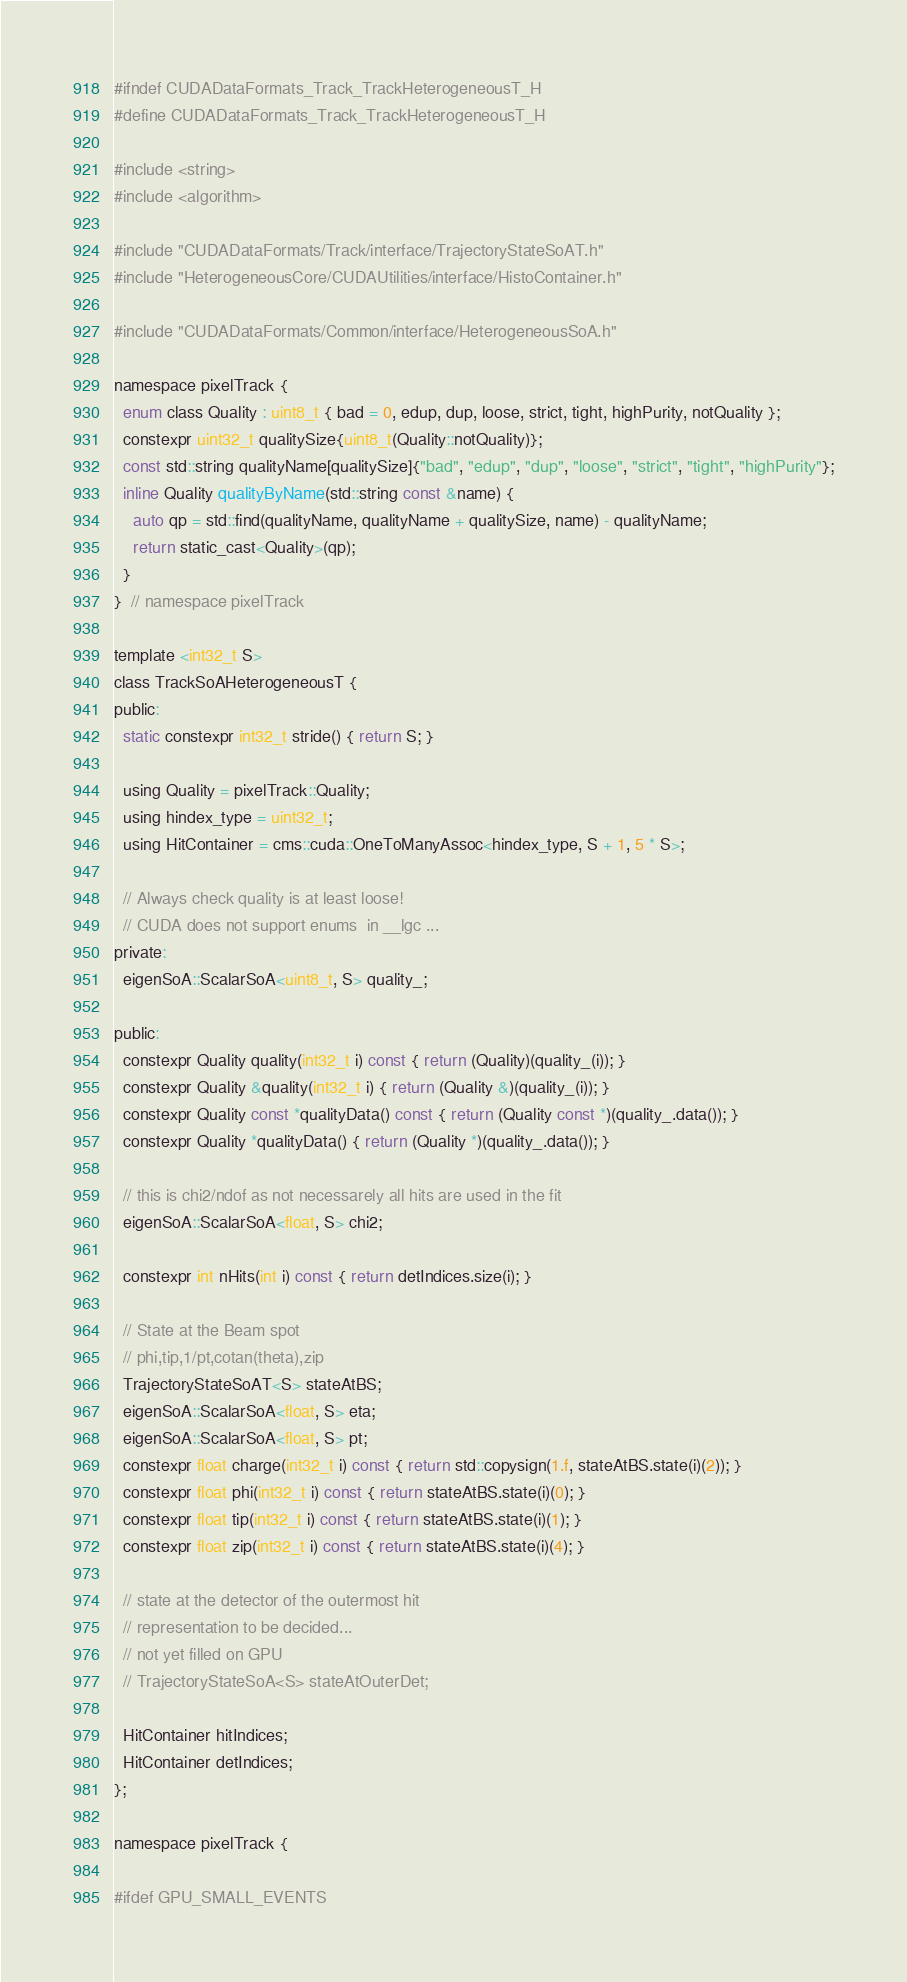<code> <loc_0><loc_0><loc_500><loc_500><_C_>#ifndef CUDADataFormats_Track_TrackHeterogeneousT_H
#define CUDADataFormats_Track_TrackHeterogeneousT_H

#include <string>
#include <algorithm>

#include "CUDADataFormats/Track/interface/TrajectoryStateSoAT.h"
#include "HeterogeneousCore/CUDAUtilities/interface/HistoContainer.h"

#include "CUDADataFormats/Common/interface/HeterogeneousSoA.h"

namespace pixelTrack {
  enum class Quality : uint8_t { bad = 0, edup, dup, loose, strict, tight, highPurity, notQuality };
  constexpr uint32_t qualitySize{uint8_t(Quality::notQuality)};
  const std::string qualityName[qualitySize]{"bad", "edup", "dup", "loose", "strict", "tight", "highPurity"};
  inline Quality qualityByName(std::string const &name) {
    auto qp = std::find(qualityName, qualityName + qualitySize, name) - qualityName;
    return static_cast<Quality>(qp);
  }
}  // namespace pixelTrack

template <int32_t S>
class TrackSoAHeterogeneousT {
public:
  static constexpr int32_t stride() { return S; }

  using Quality = pixelTrack::Quality;
  using hindex_type = uint32_t;
  using HitContainer = cms::cuda::OneToManyAssoc<hindex_type, S + 1, 5 * S>;

  // Always check quality is at least loose!
  // CUDA does not support enums  in __lgc ...
private:
  eigenSoA::ScalarSoA<uint8_t, S> quality_;

public:
  constexpr Quality quality(int32_t i) const { return (Quality)(quality_(i)); }
  constexpr Quality &quality(int32_t i) { return (Quality &)(quality_(i)); }
  constexpr Quality const *qualityData() const { return (Quality const *)(quality_.data()); }
  constexpr Quality *qualityData() { return (Quality *)(quality_.data()); }

  // this is chi2/ndof as not necessarely all hits are used in the fit
  eigenSoA::ScalarSoA<float, S> chi2;

  constexpr int nHits(int i) const { return detIndices.size(i); }

  // State at the Beam spot
  // phi,tip,1/pt,cotan(theta),zip
  TrajectoryStateSoAT<S> stateAtBS;
  eigenSoA::ScalarSoA<float, S> eta;
  eigenSoA::ScalarSoA<float, S> pt;
  constexpr float charge(int32_t i) const { return std::copysign(1.f, stateAtBS.state(i)(2)); }
  constexpr float phi(int32_t i) const { return stateAtBS.state(i)(0); }
  constexpr float tip(int32_t i) const { return stateAtBS.state(i)(1); }
  constexpr float zip(int32_t i) const { return stateAtBS.state(i)(4); }

  // state at the detector of the outermost hit
  // representation to be decided...
  // not yet filled on GPU
  // TrajectoryStateSoA<S> stateAtOuterDet;

  HitContainer hitIndices;
  HitContainer detIndices;
};

namespace pixelTrack {

#ifdef GPU_SMALL_EVENTS</code> 